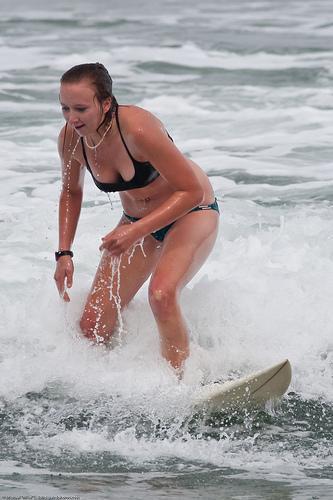How many people arer sitting on a surf board?
Give a very brief answer. 0. How many people are reading book in the sea?
Give a very brief answer. 0. How many necklaces is this girl wearing?
Give a very brief answer. 1. 